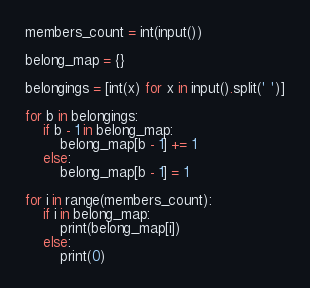<code> <loc_0><loc_0><loc_500><loc_500><_Python_>members_count = int(input())

belong_map = {}

belongings = [int(x) for x in input().split(' ')]

for b in belongings:
    if b - 1 in belong_map:
        belong_map[b - 1] += 1
    else:
        belong_map[b - 1] = 1

for i in range(members_count):
    if i in belong_map:
        print(belong_map[i])
    else:
        print(0)
</code> 